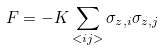<formula> <loc_0><loc_0><loc_500><loc_500>F = - K \sum _ { < i j > } \sigma _ { z , i } \sigma _ { z , j }</formula> 